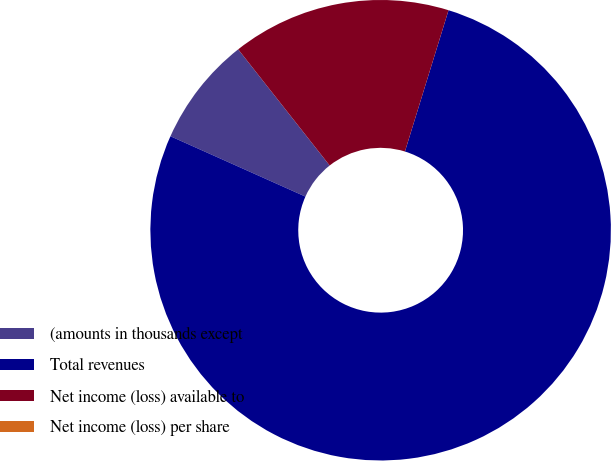<chart> <loc_0><loc_0><loc_500><loc_500><pie_chart><fcel>(amounts in thousands except<fcel>Total revenues<fcel>Net income (loss) available to<fcel>Net income (loss) per share<nl><fcel>7.69%<fcel>76.92%<fcel>15.38%<fcel>0.0%<nl></chart> 